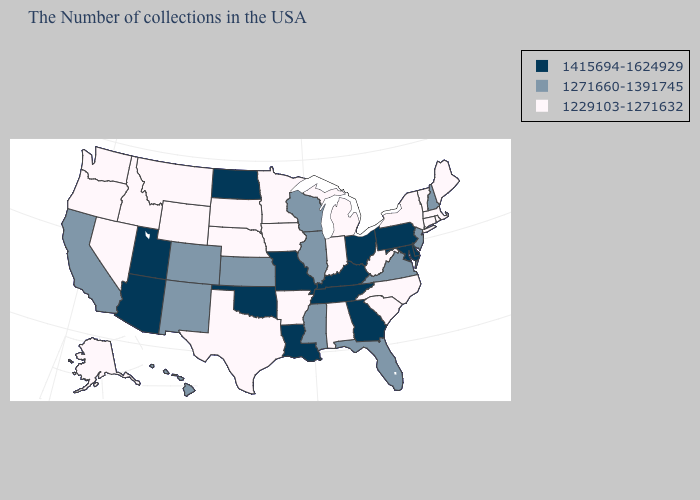What is the lowest value in the MidWest?
Keep it brief. 1229103-1271632. Does Arkansas have the same value as Rhode Island?
Write a very short answer. Yes. What is the value of Oregon?
Write a very short answer. 1229103-1271632. Name the states that have a value in the range 1415694-1624929?
Keep it brief. Delaware, Maryland, Pennsylvania, Ohio, Georgia, Kentucky, Tennessee, Louisiana, Missouri, Oklahoma, North Dakota, Utah, Arizona. Name the states that have a value in the range 1271660-1391745?
Be succinct. New Hampshire, New Jersey, Virginia, Florida, Wisconsin, Illinois, Mississippi, Kansas, Colorado, New Mexico, California, Hawaii. Among the states that border West Virginia , does Virginia have the lowest value?
Keep it brief. Yes. What is the value of Minnesota?
Give a very brief answer. 1229103-1271632. What is the value of Delaware?
Concise answer only. 1415694-1624929. Among the states that border Vermont , does New Hampshire have the lowest value?
Short answer required. No. Among the states that border Illinois , does Missouri have the lowest value?
Short answer required. No. What is the value of Alaska?
Concise answer only. 1229103-1271632. Name the states that have a value in the range 1415694-1624929?
Short answer required. Delaware, Maryland, Pennsylvania, Ohio, Georgia, Kentucky, Tennessee, Louisiana, Missouri, Oklahoma, North Dakota, Utah, Arizona. What is the highest value in states that border Connecticut?
Quick response, please. 1229103-1271632. Does the first symbol in the legend represent the smallest category?
Short answer required. No. Name the states that have a value in the range 1271660-1391745?
Concise answer only. New Hampshire, New Jersey, Virginia, Florida, Wisconsin, Illinois, Mississippi, Kansas, Colorado, New Mexico, California, Hawaii. 